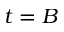<formula> <loc_0><loc_0><loc_500><loc_500>t = B</formula> 